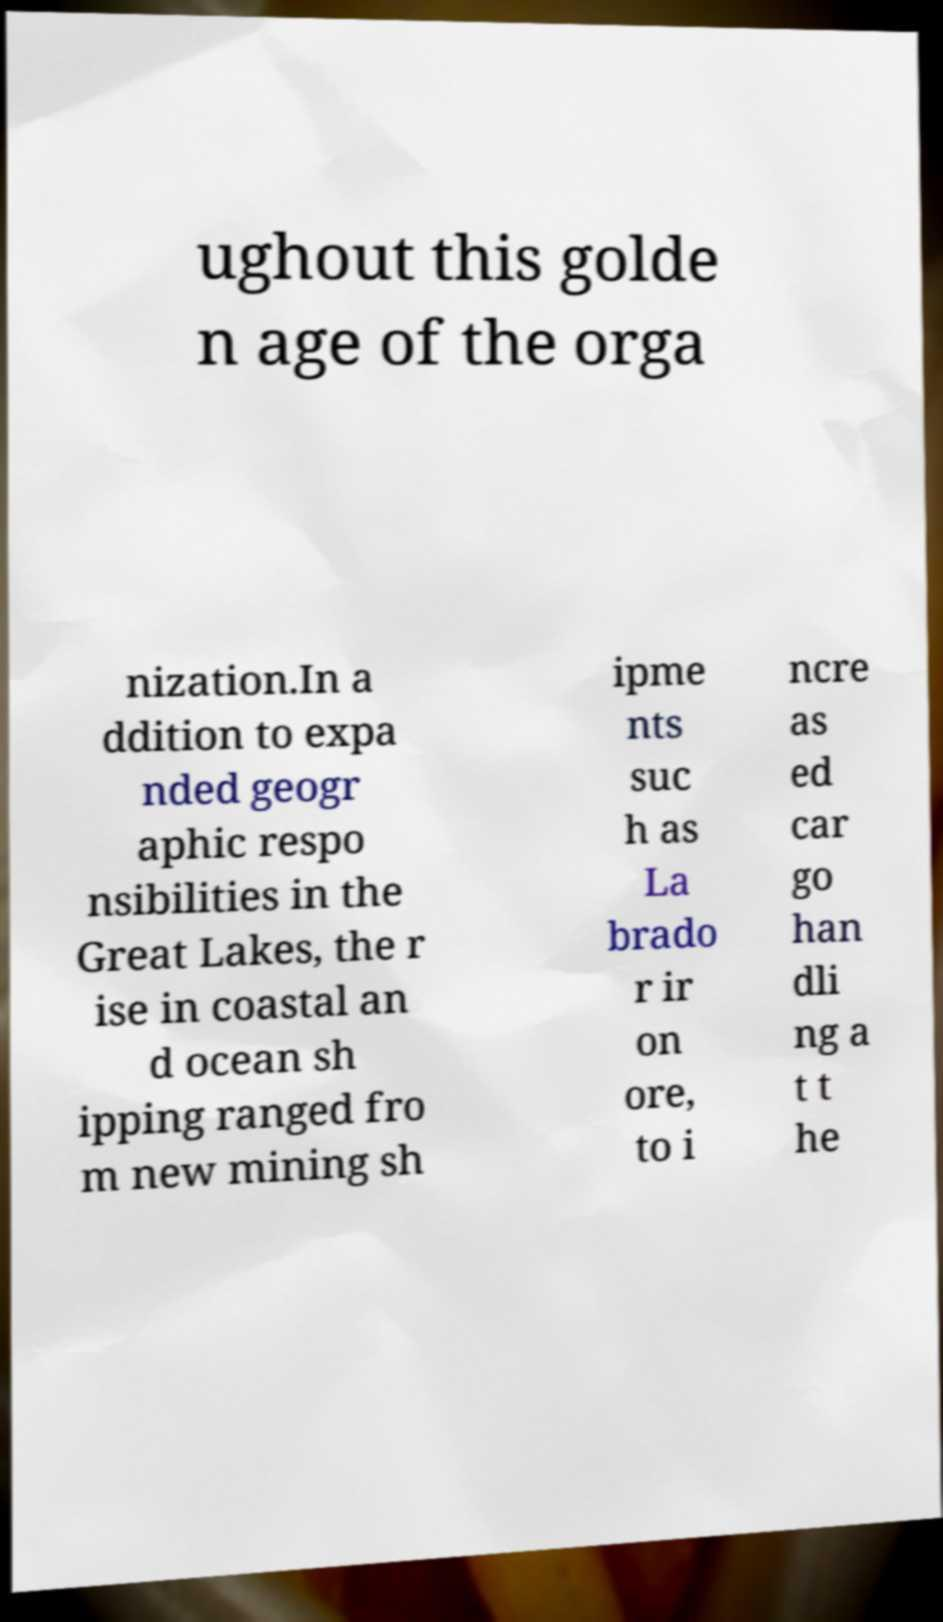What messages or text are displayed in this image? I need them in a readable, typed format. ughout this golde n age of the orga nization.In a ddition to expa nded geogr aphic respo nsibilities in the Great Lakes, the r ise in coastal an d ocean sh ipping ranged fro m new mining sh ipme nts suc h as La brado r ir on ore, to i ncre as ed car go han dli ng a t t he 